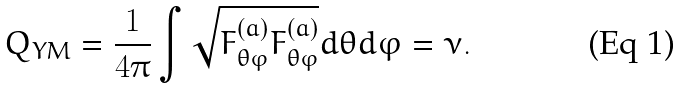Convert formula to latex. <formula><loc_0><loc_0><loc_500><loc_500>Q _ { Y M } = \frac { 1 } { 4 \pi } \int \sqrt { F _ { \theta \varphi } ^ { ( a ) } F _ { \theta \varphi } ^ { ( a ) } } d \theta d \varphi = \nu .</formula> 